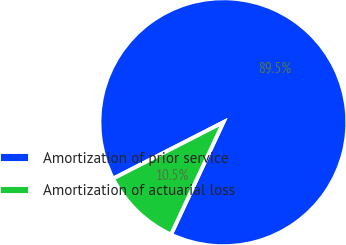Convert chart to OTSL. <chart><loc_0><loc_0><loc_500><loc_500><pie_chart><fcel>Amortization of prior service<fcel>Amortization of actuarial loss<nl><fcel>89.47%<fcel>10.53%<nl></chart> 